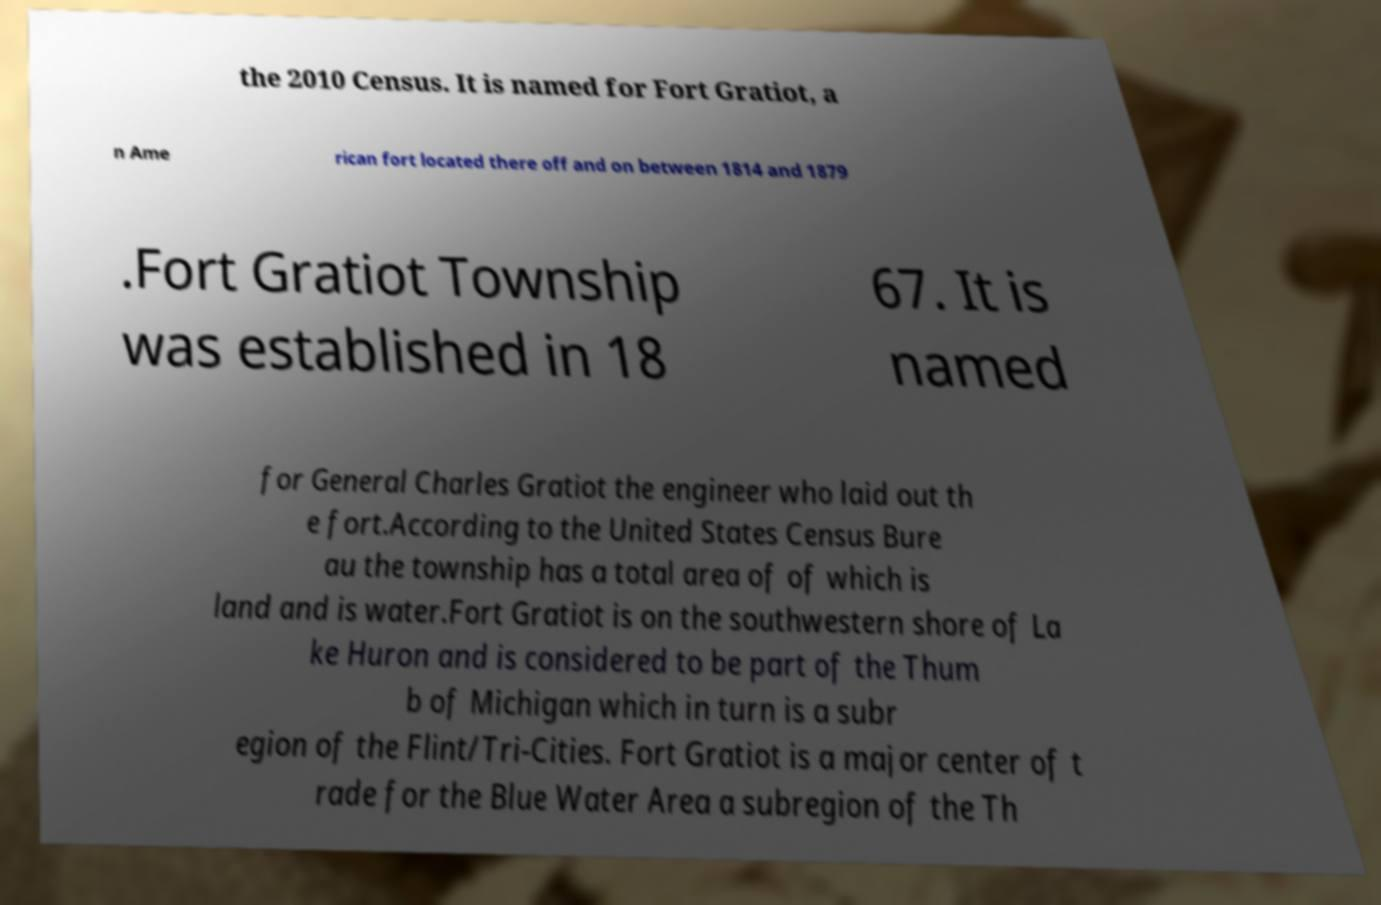Please read and relay the text visible in this image. What does it say? the 2010 Census. It is named for Fort Gratiot, a n Ame rican fort located there off and on between 1814 and 1879 .Fort Gratiot Township was established in 18 67. It is named for General Charles Gratiot the engineer who laid out th e fort.According to the United States Census Bure au the township has a total area of of which is land and is water.Fort Gratiot is on the southwestern shore of La ke Huron and is considered to be part of the Thum b of Michigan which in turn is a subr egion of the Flint/Tri-Cities. Fort Gratiot is a major center of t rade for the Blue Water Area a subregion of the Th 